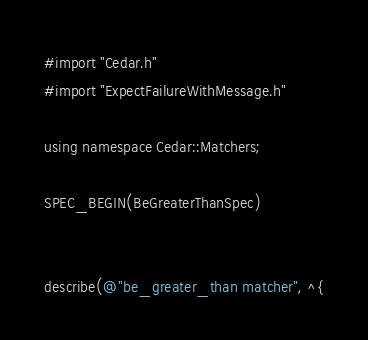Convert code to text. <code><loc_0><loc_0><loc_500><loc_500><_ObjectiveC_>#import "Cedar.h"
#import "ExpectFailureWithMessage.h"

using namespace Cedar::Matchers;

SPEC_BEGIN(BeGreaterThanSpec)


describe(@"be_greater_than matcher", ^{</code> 